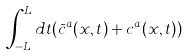Convert formula to latex. <formula><loc_0><loc_0><loc_500><loc_500>\int _ { - L } ^ { L } d t ( \bar { c } ^ { a } ( x , t ) + c ^ { a } ( x , t ) )</formula> 